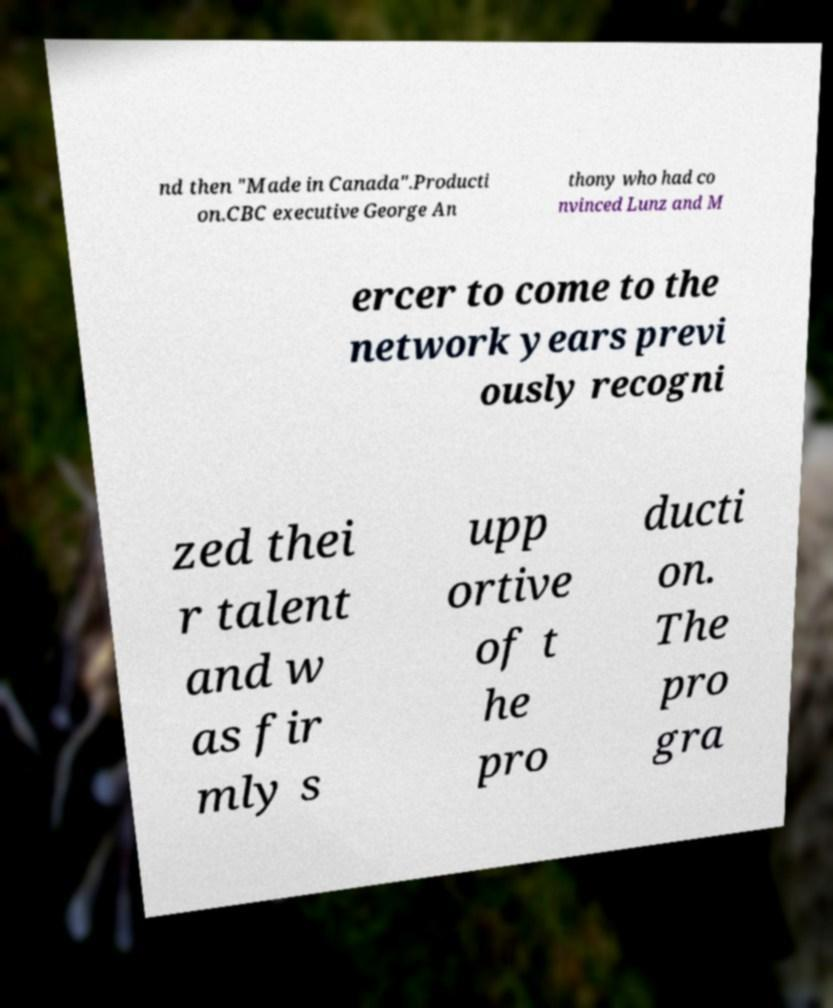I need the written content from this picture converted into text. Can you do that? nd then "Made in Canada".Producti on.CBC executive George An thony who had co nvinced Lunz and M ercer to come to the network years previ ously recogni zed thei r talent and w as fir mly s upp ortive of t he pro ducti on. The pro gra 